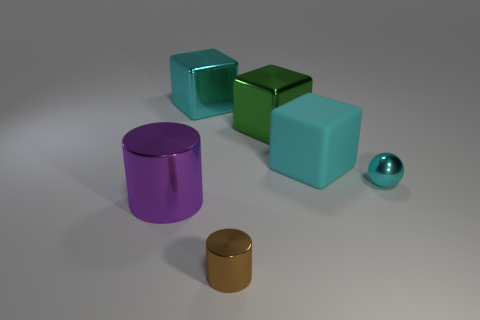How many big things are to the right of the big cyan metallic thing and in front of the large cyan rubber object?
Make the answer very short. 0. Is there any other thing that has the same size as the brown object?
Your answer should be very brief. Yes. Is the number of matte things that are behind the green shiny thing greater than the number of tiny things that are in front of the large purple metallic cylinder?
Offer a terse response. No. What is the cyan cube that is in front of the big cyan metallic block made of?
Your response must be concise. Rubber. Do the large cyan rubber thing and the cyan metal thing that is to the left of the large rubber thing have the same shape?
Provide a short and direct response. Yes. How many large shiny cubes are in front of the cyan cube in front of the big cube that is to the left of the green metal thing?
Make the answer very short. 0. What color is the other matte object that is the same shape as the large green object?
Your answer should be very brief. Cyan. Is there anything else that has the same shape as the big green object?
Give a very brief answer. Yes. What number of cylinders are either cyan metallic objects or big brown objects?
Keep it short and to the point. 0. What shape is the tiny brown object?
Make the answer very short. Cylinder. 